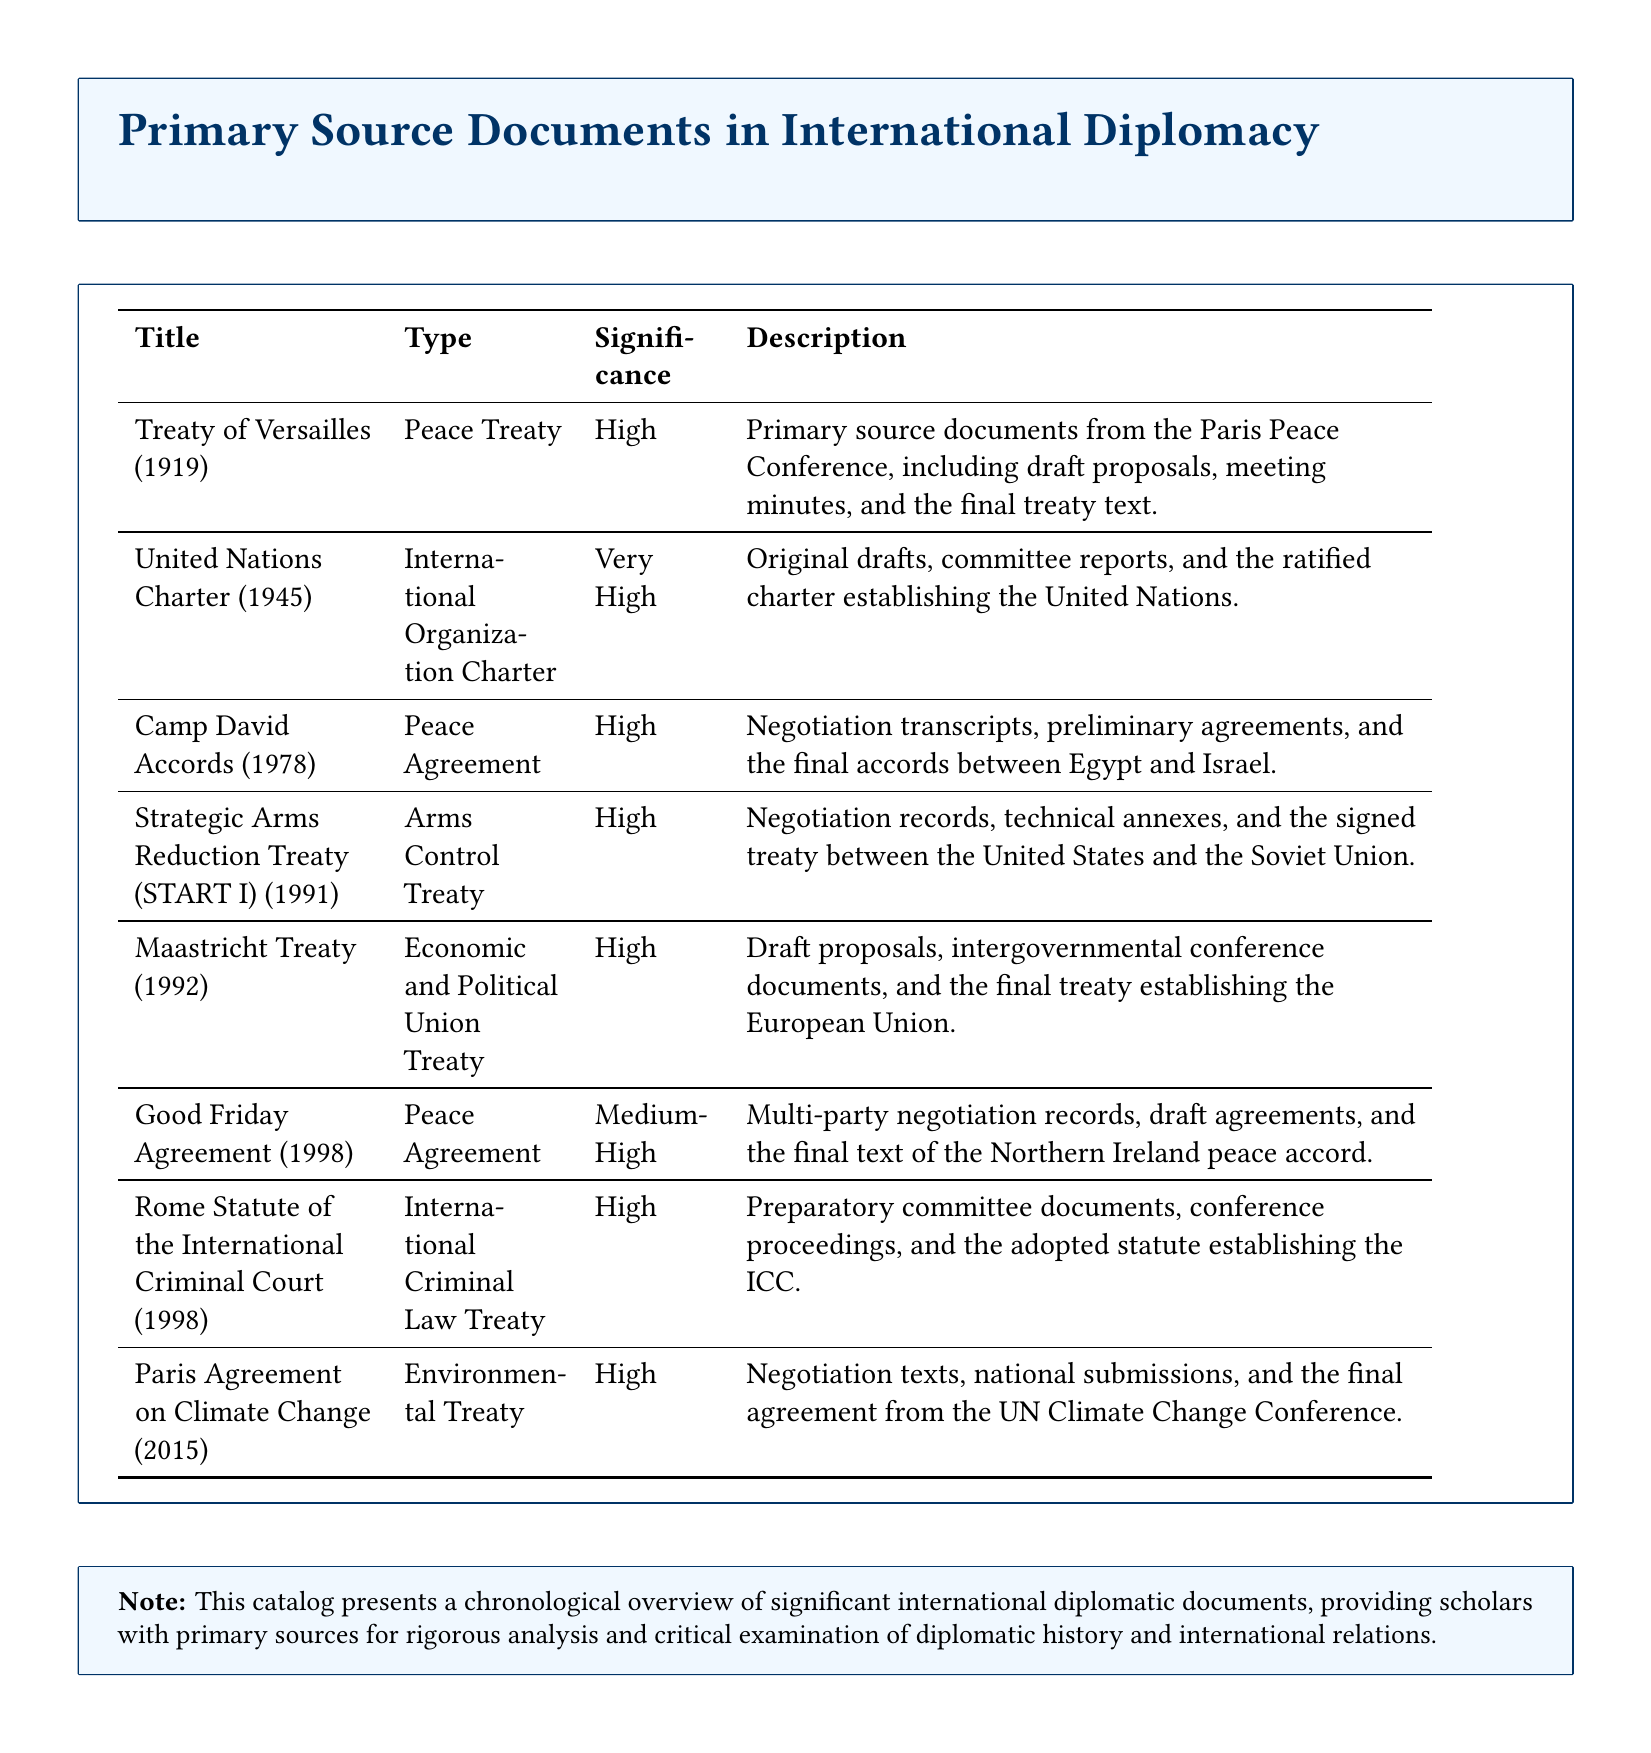What is the title of the treaty signed in 1919? The treaty signed in 1919 is listed under the title "Treaty of Versailles (1919)."
Answer: Treaty of Versailles (1919) What type of document is the United Nations Charter? The categorization of the United Nations Charter is given as an "International Organization Charter."
Answer: International Organization Charter What is the significance level of the Good Friday Agreement? The significance level of the Good Friday Agreement is classified as "Medium-High."
Answer: Medium-High In what year was the Rome Statute of the International Criminal Court adopted? The document states that the Rome Statute was adopted in 1998.
Answer: 1998 What type of agreement was signed in 1978 between Egypt and Israel? The agreement signed in 1978 is referred to as a "Peace Agreement."
Answer: Peace Agreement How many types of treaties are listed in the document? The document specifies eight different titles of treaties and agreements.
Answer: Eight What is the main subject of the Paris Agreement? The subject of the Paris Agreement focuses on "Climate Change."
Answer: Climate Change What is the document type for the Strategic Arms Reduction Treaty? The document type for the Strategic Arms Reduction Treaty is labeled as "Arms Control Treaty."
Answer: Arms Control Treaty 